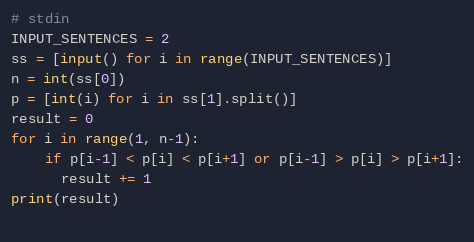<code> <loc_0><loc_0><loc_500><loc_500><_Python_># stdin
INPUT_SENTENCES = 2
ss = [input() for i in range(INPUT_SENTENCES)]
n = int(ss[0])
p = [int(i) for i in ss[1].split()]
result = 0
for i in range(1, n-1):
    if p[i-1] < p[i] < p[i+1] or p[i-1] > p[i] > p[i+1]:
      result += 1
print(result)
    
</code> 